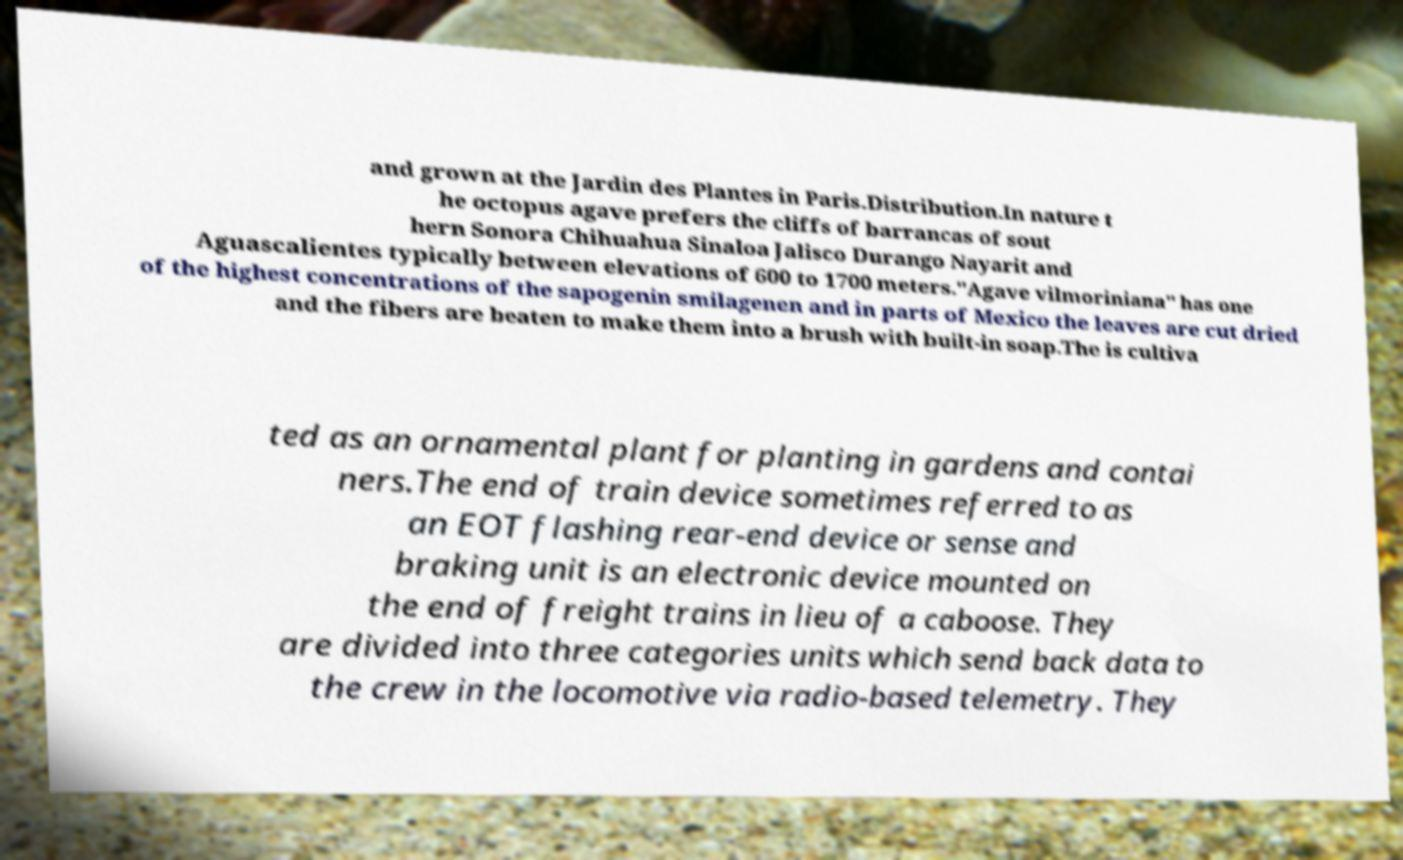What messages or text are displayed in this image? I need them in a readable, typed format. and grown at the Jardin des Plantes in Paris.Distribution.In nature t he octopus agave prefers the cliffs of barrancas of sout hern Sonora Chihuahua Sinaloa Jalisco Durango Nayarit and Aguascalientes typically between elevations of 600 to 1700 meters."Agave vilmoriniana" has one of the highest concentrations of the sapogenin smilagenen and in parts of Mexico the leaves are cut dried and the fibers are beaten to make them into a brush with built-in soap.The is cultiva ted as an ornamental plant for planting in gardens and contai ners.The end of train device sometimes referred to as an EOT flashing rear-end device or sense and braking unit is an electronic device mounted on the end of freight trains in lieu of a caboose. They are divided into three categories units which send back data to the crew in the locomotive via radio-based telemetry. They 